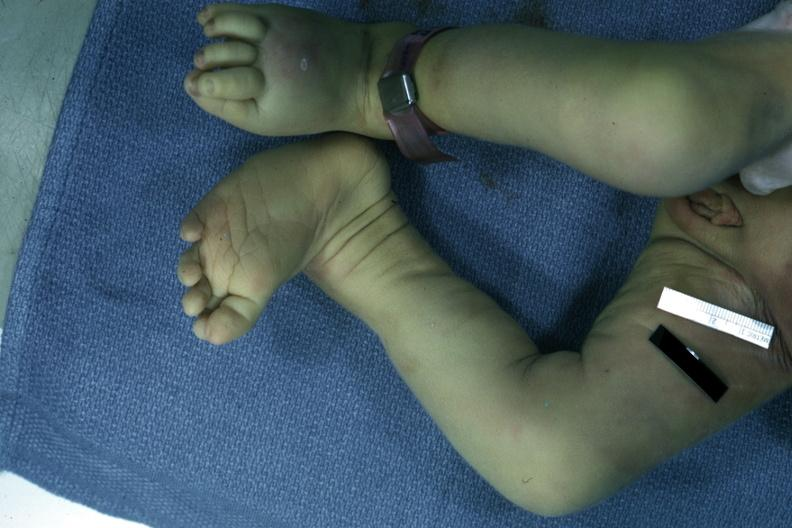what are present?
Answer the question using a single word or phrase. Extremities 